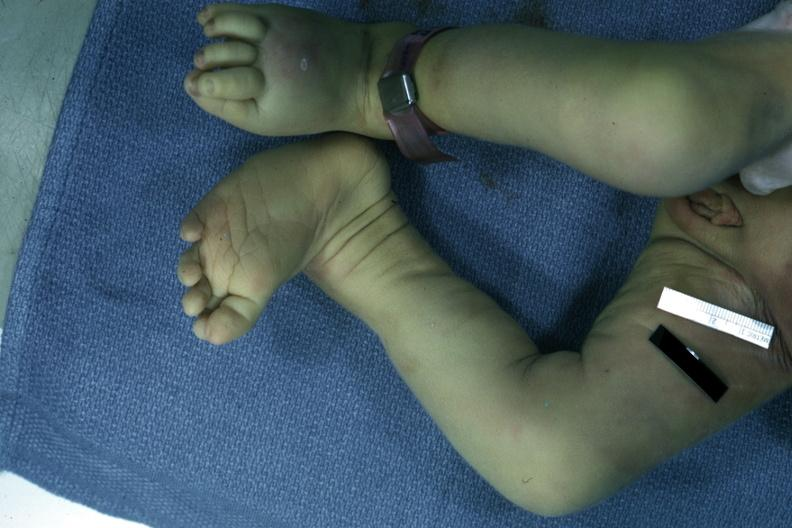what are present?
Answer the question using a single word or phrase. Extremities 